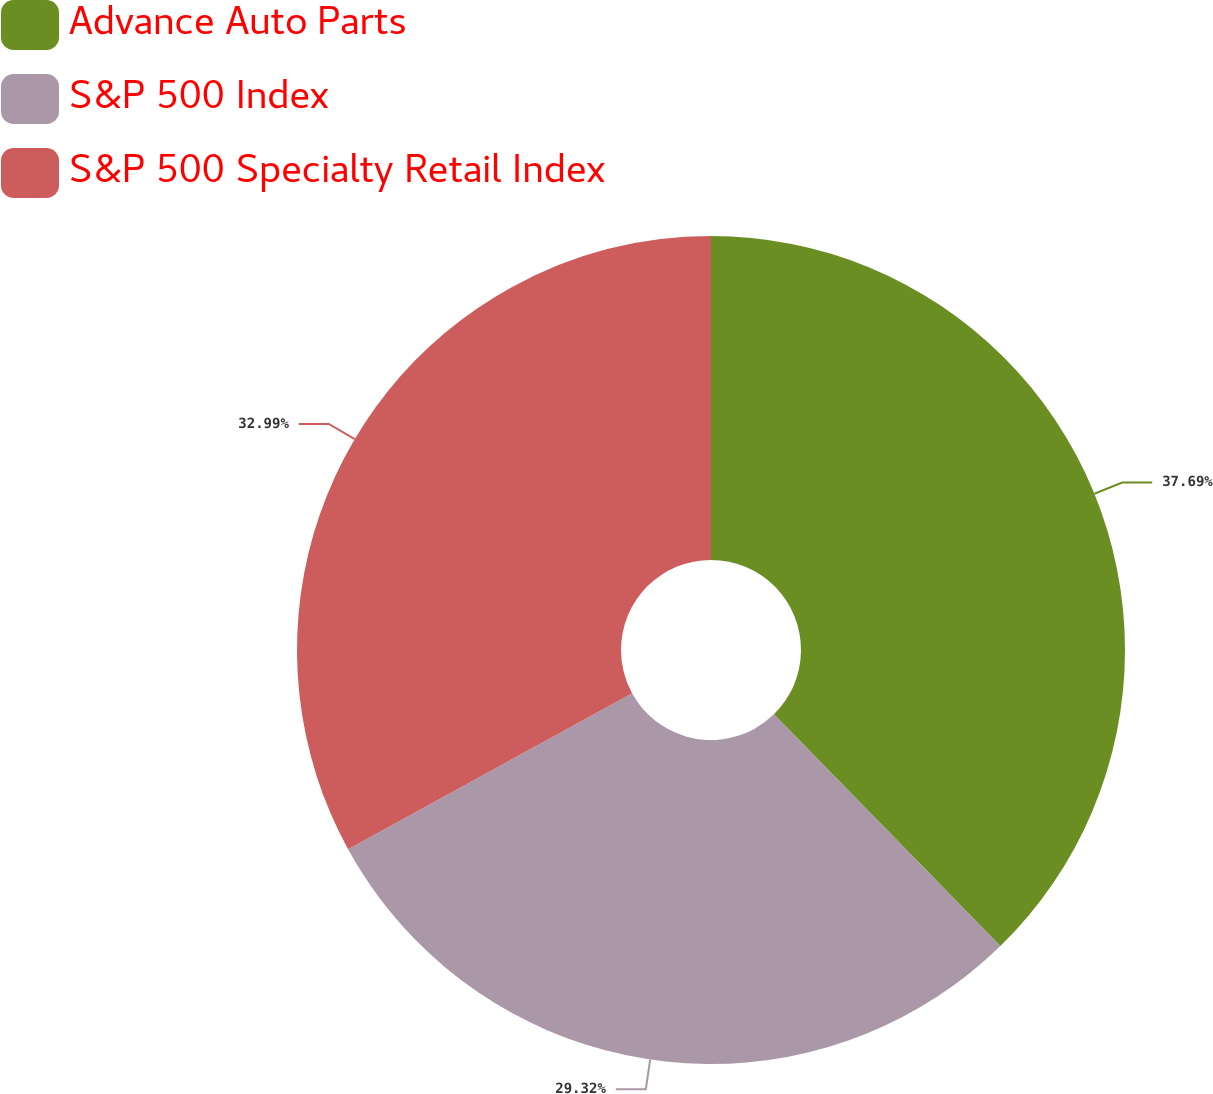Convert chart to OTSL. <chart><loc_0><loc_0><loc_500><loc_500><pie_chart><fcel>Advance Auto Parts<fcel>S&P 500 Index<fcel>S&P 500 Specialty Retail Index<nl><fcel>37.68%<fcel>29.32%<fcel>32.99%<nl></chart> 